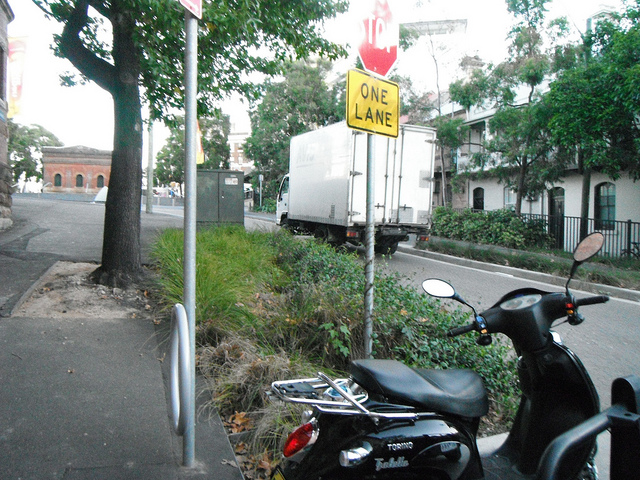Please identify all text content in this image. ONE 